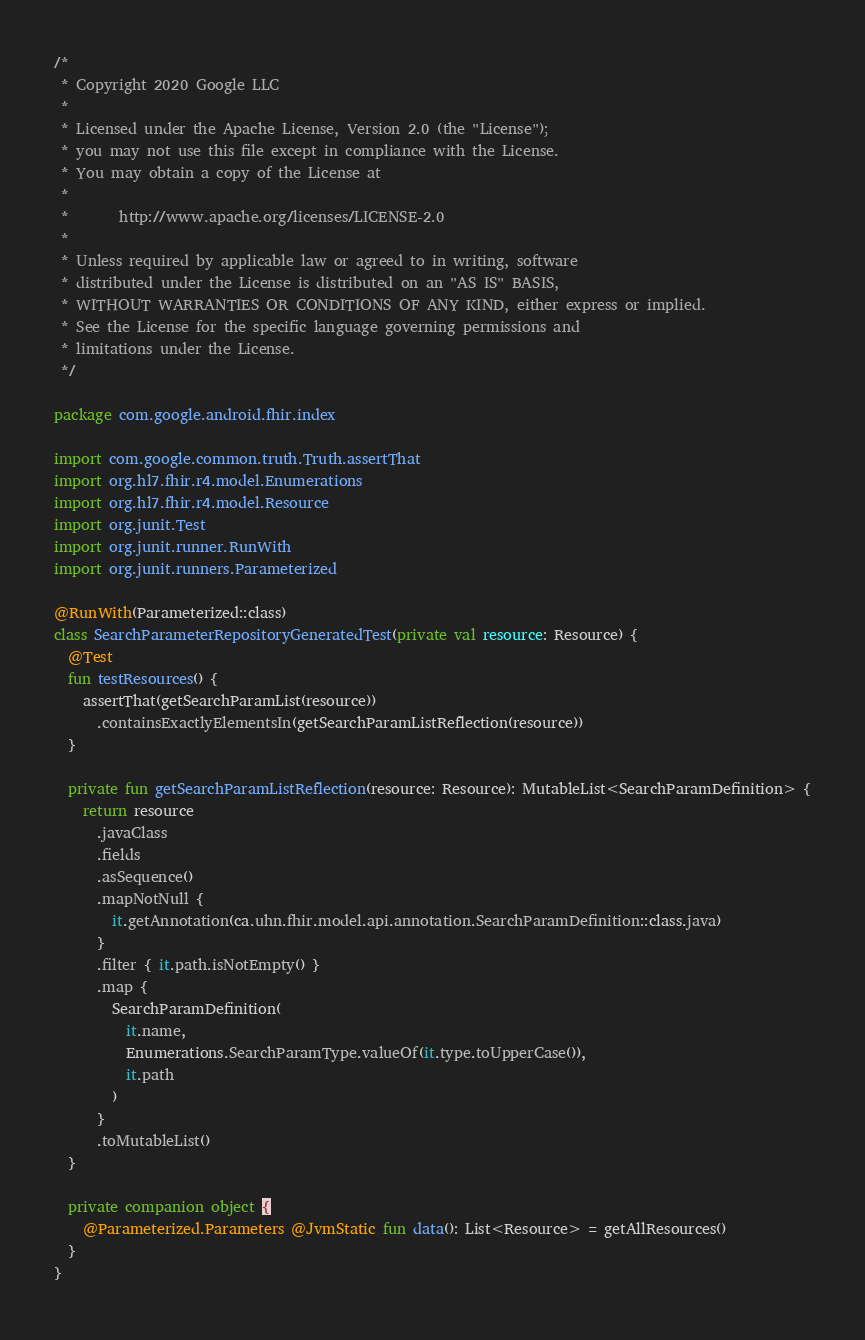<code> <loc_0><loc_0><loc_500><loc_500><_Kotlin_>/*
 * Copyright 2020 Google LLC
 *
 * Licensed under the Apache License, Version 2.0 (the "License");
 * you may not use this file except in compliance with the License.
 * You may obtain a copy of the License at
 *
 *       http://www.apache.org/licenses/LICENSE-2.0
 *
 * Unless required by applicable law or agreed to in writing, software
 * distributed under the License is distributed on an "AS IS" BASIS,
 * WITHOUT WARRANTIES OR CONDITIONS OF ANY KIND, either express or implied.
 * See the License for the specific language governing permissions and
 * limitations under the License.
 */

package com.google.android.fhir.index

import com.google.common.truth.Truth.assertThat
import org.hl7.fhir.r4.model.Enumerations
import org.hl7.fhir.r4.model.Resource
import org.junit.Test
import org.junit.runner.RunWith
import org.junit.runners.Parameterized

@RunWith(Parameterized::class)
class SearchParameterRepositoryGeneratedTest(private val resource: Resource) {
  @Test
  fun testResources() {
    assertThat(getSearchParamList(resource))
      .containsExactlyElementsIn(getSearchParamListReflection(resource))
  }

  private fun getSearchParamListReflection(resource: Resource): MutableList<SearchParamDefinition> {
    return resource
      .javaClass
      .fields
      .asSequence()
      .mapNotNull {
        it.getAnnotation(ca.uhn.fhir.model.api.annotation.SearchParamDefinition::class.java)
      }
      .filter { it.path.isNotEmpty() }
      .map {
        SearchParamDefinition(
          it.name,
          Enumerations.SearchParamType.valueOf(it.type.toUpperCase()),
          it.path
        )
      }
      .toMutableList()
  }

  private companion object {
    @Parameterized.Parameters @JvmStatic fun data(): List<Resource> = getAllResources()
  }
}
</code> 